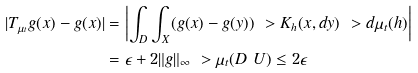<formula> <loc_0><loc_0><loc_500><loc_500>| T _ { \mu _ { t } } g ( x ) - g ( x ) | & = \left | \int _ { D } \int _ { X } ( g ( x ) - g ( y ) ) \ > K _ { h } ( x , d y ) \ > d \mu _ { t } ( h ) \right | \\ & = \epsilon + 2 \| g \| _ { \infty } \ > \mu _ { t } ( D \ U ) \leq 2 \epsilon</formula> 